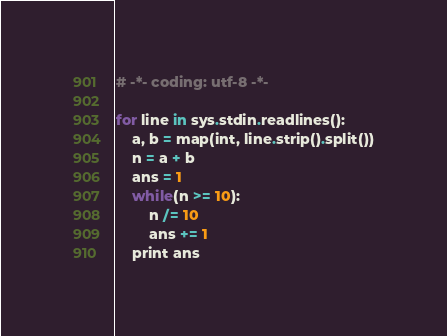Convert code to text. <code><loc_0><loc_0><loc_500><loc_500><_Python_># -*- coding: utf-8 -*-

for line in sys.stdin.readlines():
    a, b = map(int, line.strip().split())
    n = a + b
    ans = 1
    while(n >= 10):
        n /= 10
        ans += 1
    print ans</code> 